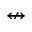Convert formula to latex. <formula><loc_0><loc_0><loc_500><loc_500>\ n l e f t r i g h t a r r o w</formula> 